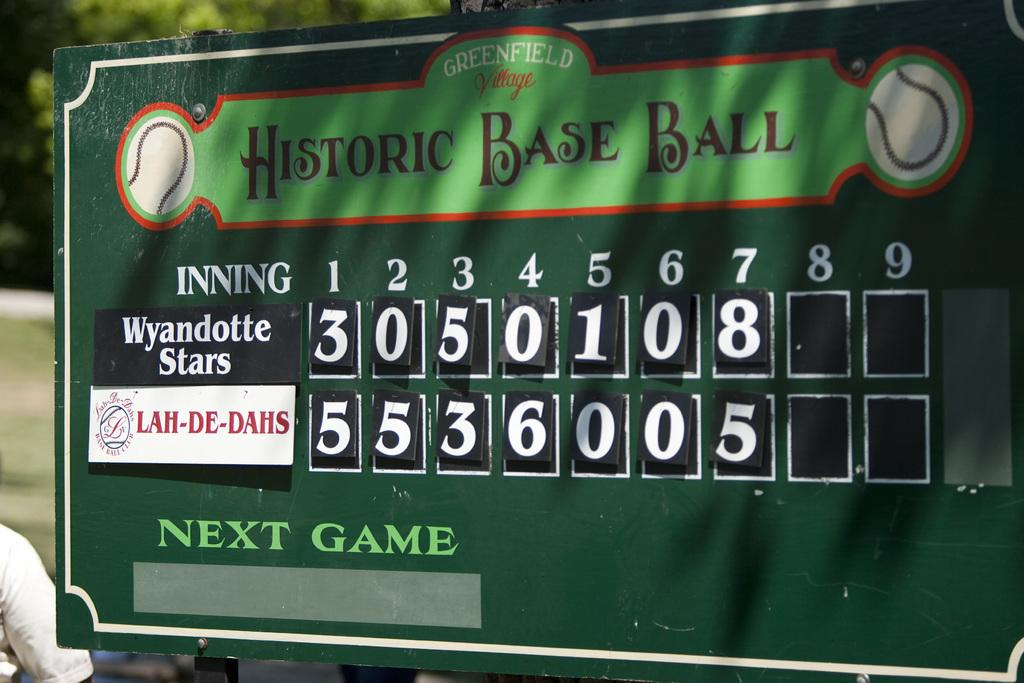<image>
Share a concise interpretation of the image provided. A green baseball scoreboard with two teams and their scores for seven of nine innings. 